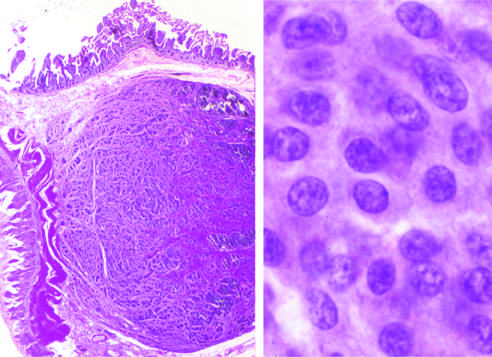does high magnification show the bland cytology that typifies neuroendocrine tumors?
Answer the question using a single word or phrase. Yes 